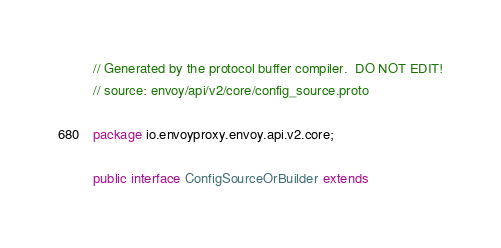Convert code to text. <code><loc_0><loc_0><loc_500><loc_500><_Java_>// Generated by the protocol buffer compiler.  DO NOT EDIT!
// source: envoy/api/v2/core/config_source.proto

package io.envoyproxy.envoy.api.v2.core;

public interface ConfigSourceOrBuilder extends</code> 